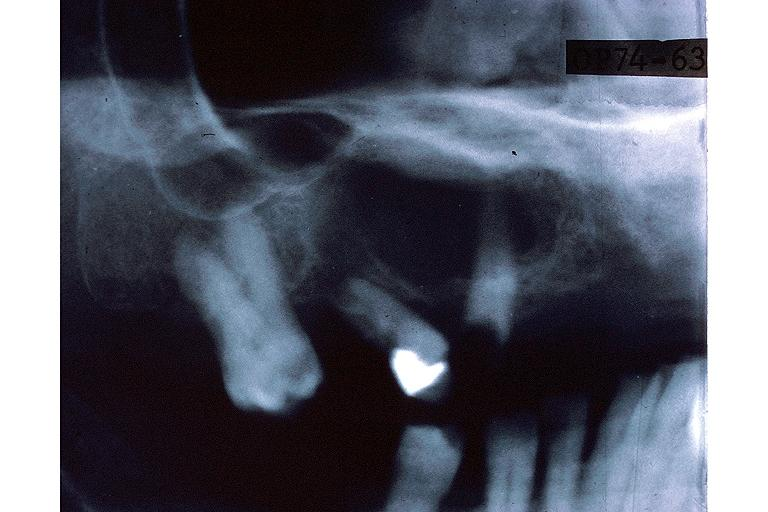does this image show central giant cell lesion?
Answer the question using a single word or phrase. Yes 